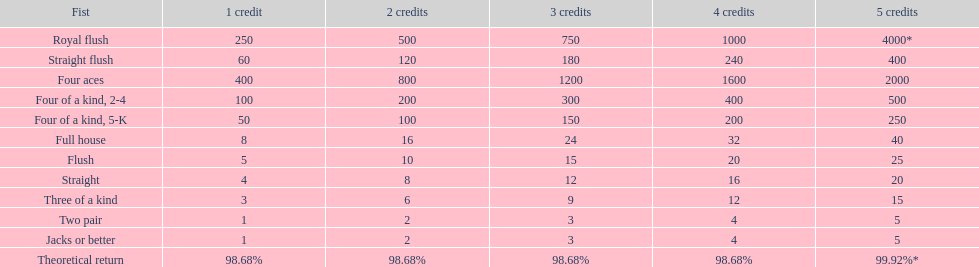What is the total amount of a 3 credit straight flush? 180. 